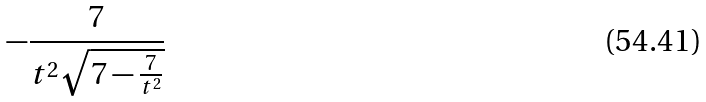<formula> <loc_0><loc_0><loc_500><loc_500>- \frac { 7 } { t ^ { 2 } \sqrt { 7 - \frac { 7 } { t ^ { 2 } } } }</formula> 